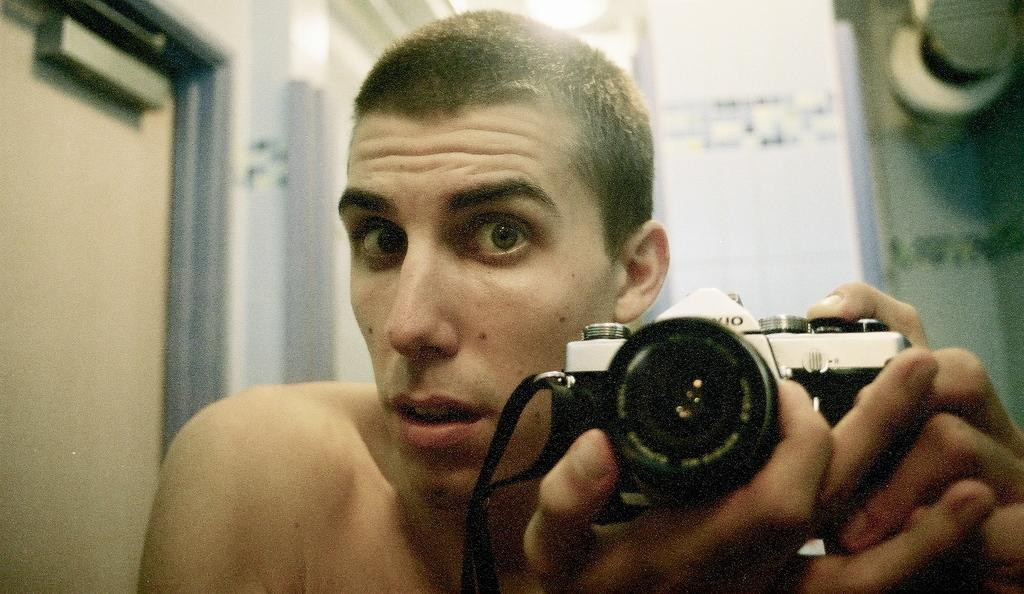Who is present in the image? There is a man in the image. What is the man holding in his hands? The man is holding a camera in his hands. What architectural feature can be seen in the image? There is a door in the image. What can be seen in the background of the image? There is a wall visible in the background of the image. What is the price of the shoes the man is wearing in the image? There is no information about shoes in the image, so we cannot determine the price of any shoes the man might be wearing. 